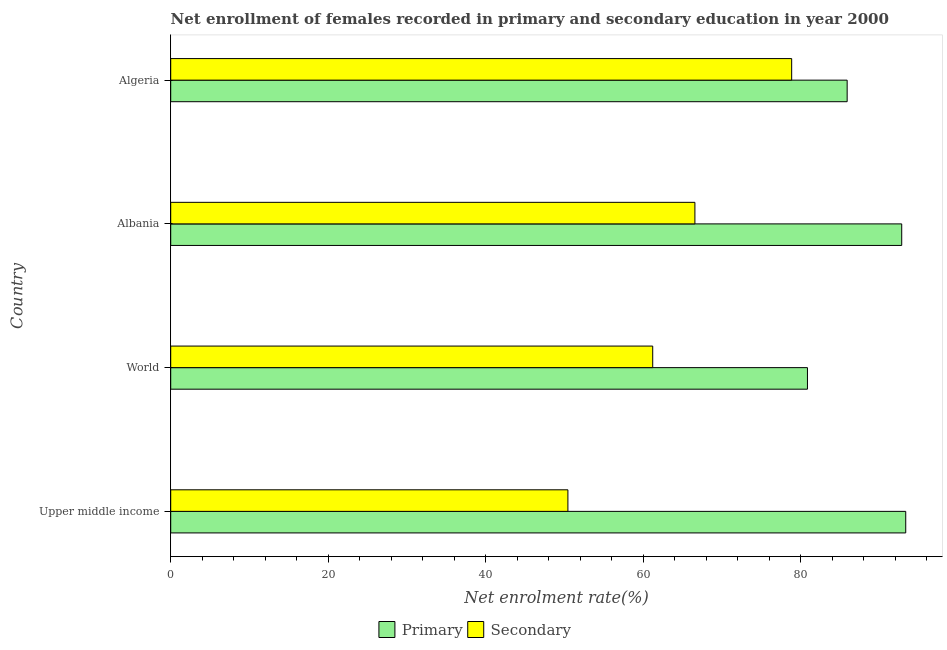How many bars are there on the 3rd tick from the top?
Provide a short and direct response. 2. How many bars are there on the 3rd tick from the bottom?
Make the answer very short. 2. What is the label of the 1st group of bars from the top?
Your answer should be compact. Algeria. In how many cases, is the number of bars for a given country not equal to the number of legend labels?
Make the answer very short. 0. What is the enrollment rate in primary education in Algeria?
Ensure brevity in your answer.  85.89. Across all countries, what is the maximum enrollment rate in secondary education?
Your answer should be compact. 78.84. Across all countries, what is the minimum enrollment rate in secondary education?
Offer a very short reply. 50.43. In which country was the enrollment rate in secondary education maximum?
Offer a terse response. Algeria. In which country was the enrollment rate in primary education minimum?
Your answer should be compact. World. What is the total enrollment rate in secondary education in the graph?
Your response must be concise. 257.03. What is the difference between the enrollment rate in secondary education in Algeria and that in World?
Your response must be concise. 17.64. What is the difference between the enrollment rate in secondary education in Albania and the enrollment rate in primary education in Upper middle income?
Provide a short and direct response. -26.77. What is the average enrollment rate in primary education per country?
Your answer should be very brief. 88.22. What is the difference between the enrollment rate in secondary education and enrollment rate in primary education in Upper middle income?
Offer a very short reply. -42.89. What is the ratio of the enrollment rate in secondary education in Albania to that in Algeria?
Provide a succinct answer. 0.84. Is the difference between the enrollment rate in primary education in Algeria and Upper middle income greater than the difference between the enrollment rate in secondary education in Algeria and Upper middle income?
Give a very brief answer. No. What is the difference between the highest and the second highest enrollment rate in secondary education?
Provide a short and direct response. 12.29. What is the difference between the highest and the lowest enrollment rate in primary education?
Give a very brief answer. 12.48. In how many countries, is the enrollment rate in primary education greater than the average enrollment rate in primary education taken over all countries?
Provide a short and direct response. 2. Is the sum of the enrollment rate in primary education in Albania and Algeria greater than the maximum enrollment rate in secondary education across all countries?
Give a very brief answer. Yes. What does the 1st bar from the top in Albania represents?
Make the answer very short. Secondary. What does the 2nd bar from the bottom in Albania represents?
Offer a very short reply. Secondary. Are all the bars in the graph horizontal?
Your answer should be very brief. Yes. How many countries are there in the graph?
Your answer should be compact. 4. What is the difference between two consecutive major ticks on the X-axis?
Offer a very short reply. 20. Are the values on the major ticks of X-axis written in scientific E-notation?
Give a very brief answer. No. Does the graph contain any zero values?
Give a very brief answer. No. Does the graph contain grids?
Provide a short and direct response. No. How are the legend labels stacked?
Make the answer very short. Horizontal. What is the title of the graph?
Your response must be concise. Net enrollment of females recorded in primary and secondary education in year 2000. Does "Frequency of shipment arrival" appear as one of the legend labels in the graph?
Offer a very short reply. No. What is the label or title of the X-axis?
Your answer should be compact. Net enrolment rate(%). What is the label or title of the Y-axis?
Your answer should be compact. Country. What is the Net enrolment rate(%) of Primary in Upper middle income?
Your answer should be compact. 93.33. What is the Net enrolment rate(%) of Secondary in Upper middle income?
Your answer should be compact. 50.43. What is the Net enrolment rate(%) in Primary in World?
Give a very brief answer. 80.85. What is the Net enrolment rate(%) of Secondary in World?
Offer a terse response. 61.2. What is the Net enrolment rate(%) in Primary in Albania?
Provide a short and direct response. 92.82. What is the Net enrolment rate(%) of Secondary in Albania?
Ensure brevity in your answer.  66.56. What is the Net enrolment rate(%) of Primary in Algeria?
Your answer should be very brief. 85.89. What is the Net enrolment rate(%) in Secondary in Algeria?
Provide a succinct answer. 78.84. Across all countries, what is the maximum Net enrolment rate(%) in Primary?
Your response must be concise. 93.33. Across all countries, what is the maximum Net enrolment rate(%) in Secondary?
Give a very brief answer. 78.84. Across all countries, what is the minimum Net enrolment rate(%) of Primary?
Offer a terse response. 80.85. Across all countries, what is the minimum Net enrolment rate(%) of Secondary?
Offer a very short reply. 50.43. What is the total Net enrolment rate(%) of Primary in the graph?
Make the answer very short. 352.87. What is the total Net enrolment rate(%) in Secondary in the graph?
Ensure brevity in your answer.  257.03. What is the difference between the Net enrolment rate(%) in Primary in Upper middle income and that in World?
Provide a short and direct response. 12.48. What is the difference between the Net enrolment rate(%) in Secondary in Upper middle income and that in World?
Provide a succinct answer. -10.77. What is the difference between the Net enrolment rate(%) of Primary in Upper middle income and that in Albania?
Offer a terse response. 0.51. What is the difference between the Net enrolment rate(%) in Secondary in Upper middle income and that in Albania?
Your answer should be very brief. -16.12. What is the difference between the Net enrolment rate(%) of Primary in Upper middle income and that in Algeria?
Offer a terse response. 7.44. What is the difference between the Net enrolment rate(%) of Secondary in Upper middle income and that in Algeria?
Make the answer very short. -28.41. What is the difference between the Net enrolment rate(%) of Primary in World and that in Albania?
Offer a very short reply. -11.97. What is the difference between the Net enrolment rate(%) in Secondary in World and that in Albania?
Offer a very short reply. -5.36. What is the difference between the Net enrolment rate(%) of Primary in World and that in Algeria?
Give a very brief answer. -5.04. What is the difference between the Net enrolment rate(%) in Secondary in World and that in Algeria?
Ensure brevity in your answer.  -17.64. What is the difference between the Net enrolment rate(%) in Primary in Albania and that in Algeria?
Keep it short and to the point. 6.93. What is the difference between the Net enrolment rate(%) of Secondary in Albania and that in Algeria?
Make the answer very short. -12.29. What is the difference between the Net enrolment rate(%) in Primary in Upper middle income and the Net enrolment rate(%) in Secondary in World?
Offer a terse response. 32.13. What is the difference between the Net enrolment rate(%) of Primary in Upper middle income and the Net enrolment rate(%) of Secondary in Albania?
Ensure brevity in your answer.  26.77. What is the difference between the Net enrolment rate(%) of Primary in Upper middle income and the Net enrolment rate(%) of Secondary in Algeria?
Your response must be concise. 14.48. What is the difference between the Net enrolment rate(%) of Primary in World and the Net enrolment rate(%) of Secondary in Albania?
Your answer should be very brief. 14.29. What is the difference between the Net enrolment rate(%) of Primary in World and the Net enrolment rate(%) of Secondary in Algeria?
Ensure brevity in your answer.  2. What is the difference between the Net enrolment rate(%) of Primary in Albania and the Net enrolment rate(%) of Secondary in Algeria?
Provide a short and direct response. 13.97. What is the average Net enrolment rate(%) of Primary per country?
Give a very brief answer. 88.22. What is the average Net enrolment rate(%) of Secondary per country?
Ensure brevity in your answer.  64.26. What is the difference between the Net enrolment rate(%) of Primary and Net enrolment rate(%) of Secondary in Upper middle income?
Offer a very short reply. 42.89. What is the difference between the Net enrolment rate(%) of Primary and Net enrolment rate(%) of Secondary in World?
Your response must be concise. 19.65. What is the difference between the Net enrolment rate(%) in Primary and Net enrolment rate(%) in Secondary in Albania?
Give a very brief answer. 26.26. What is the difference between the Net enrolment rate(%) of Primary and Net enrolment rate(%) of Secondary in Algeria?
Provide a short and direct response. 7.04. What is the ratio of the Net enrolment rate(%) in Primary in Upper middle income to that in World?
Offer a very short reply. 1.15. What is the ratio of the Net enrolment rate(%) of Secondary in Upper middle income to that in World?
Your response must be concise. 0.82. What is the ratio of the Net enrolment rate(%) of Secondary in Upper middle income to that in Albania?
Provide a short and direct response. 0.76. What is the ratio of the Net enrolment rate(%) in Primary in Upper middle income to that in Algeria?
Your response must be concise. 1.09. What is the ratio of the Net enrolment rate(%) in Secondary in Upper middle income to that in Algeria?
Give a very brief answer. 0.64. What is the ratio of the Net enrolment rate(%) in Primary in World to that in Albania?
Provide a short and direct response. 0.87. What is the ratio of the Net enrolment rate(%) of Secondary in World to that in Albania?
Your response must be concise. 0.92. What is the ratio of the Net enrolment rate(%) in Primary in World to that in Algeria?
Ensure brevity in your answer.  0.94. What is the ratio of the Net enrolment rate(%) in Secondary in World to that in Algeria?
Your answer should be very brief. 0.78. What is the ratio of the Net enrolment rate(%) in Primary in Albania to that in Algeria?
Your answer should be very brief. 1.08. What is the ratio of the Net enrolment rate(%) of Secondary in Albania to that in Algeria?
Make the answer very short. 0.84. What is the difference between the highest and the second highest Net enrolment rate(%) of Primary?
Offer a very short reply. 0.51. What is the difference between the highest and the second highest Net enrolment rate(%) of Secondary?
Offer a very short reply. 12.29. What is the difference between the highest and the lowest Net enrolment rate(%) of Primary?
Provide a succinct answer. 12.48. What is the difference between the highest and the lowest Net enrolment rate(%) of Secondary?
Provide a succinct answer. 28.41. 